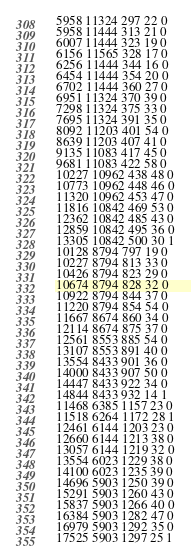Convert code to text. <code><loc_0><loc_0><loc_500><loc_500><_SML_>5958 11324 297 22 0
5958 11444 313 21 0
6007 11444 323 19 0
6156 11565 328 17 0
6256 11444 344 16 0
6454 11444 354 20 0
6702 11444 360 27 0
6951 11324 370 39 0
7298 11324 375 33 0
7695 11324 391 35 0
8092 11203 401 54 0
8639 11203 407 41 0
9135 11083 417 45 0
9681 11083 422 58 0
10227 10962 438 48 0
10773 10962 448 46 0
11320 10962 453 47 0
11816 10842 469 53 0
12362 10842 485 43 0
12859 10842 495 36 0
13305 10842 500 30 1
10128 8794 797 19 0
10227 8794 813 33 0
10426 8794 823 29 0
10674 8794 828 32 0
10922 8794 844 37 0
11220 8794 854 54 0
11667 8674 860 34 0
12114 8674 875 37 0
12561 8553 885 54 0
13107 8553 891 40 0
13554 8433 901 36 0
14000 8433 907 50 0
14447 8433 922 34 0
14844 8433 932 14 1
11468 6385 1157 23 0
11518 6264 1172 28 1
12461 6144 1203 23 0
12660 6144 1213 38 0
13057 6144 1219 32 0
13554 6023 1229 38 0
14100 6023 1235 39 0
14696 5903 1250 39 0
15291 5903 1260 43 0
15837 5903 1266 40 0
16384 5903 1282 47 0
16979 5903 1292 35 0
17525 5903 1297 25 1</code> 